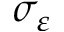Convert formula to latex. <formula><loc_0><loc_0><loc_500><loc_500>\sigma _ { \varepsilon }</formula> 